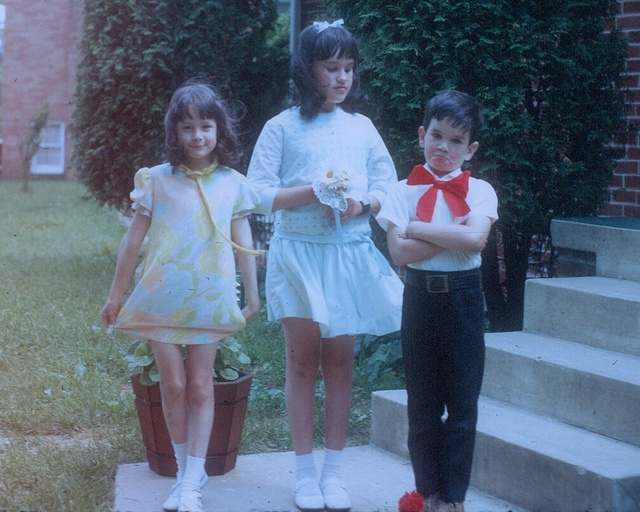Describe the objects in this image and their specific colors. I can see people in darkgray, lightblue, and gray tones, people in darkgray, gray, and lightblue tones, people in darkgray, black, navy, and gray tones, potted plant in darkgray, gray, purple, and black tones, and tie in darkgray, brown, and violet tones in this image. 